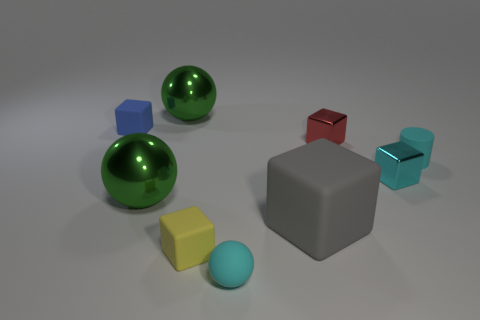Subtract all blue rubber cubes. How many cubes are left? 4 Subtract all cyan blocks. How many green balls are left? 2 Subtract 1 cubes. How many cubes are left? 4 Subtract all yellow blocks. How many blocks are left? 4 Add 1 cyan rubber things. How many objects exist? 10 Subtract all gray spheres. Subtract all gray blocks. How many spheres are left? 3 Subtract all cylinders. How many objects are left? 8 Subtract all cyan metallic things. Subtract all big gray things. How many objects are left? 7 Add 7 green balls. How many green balls are left? 9 Add 6 small spheres. How many small spheres exist? 7 